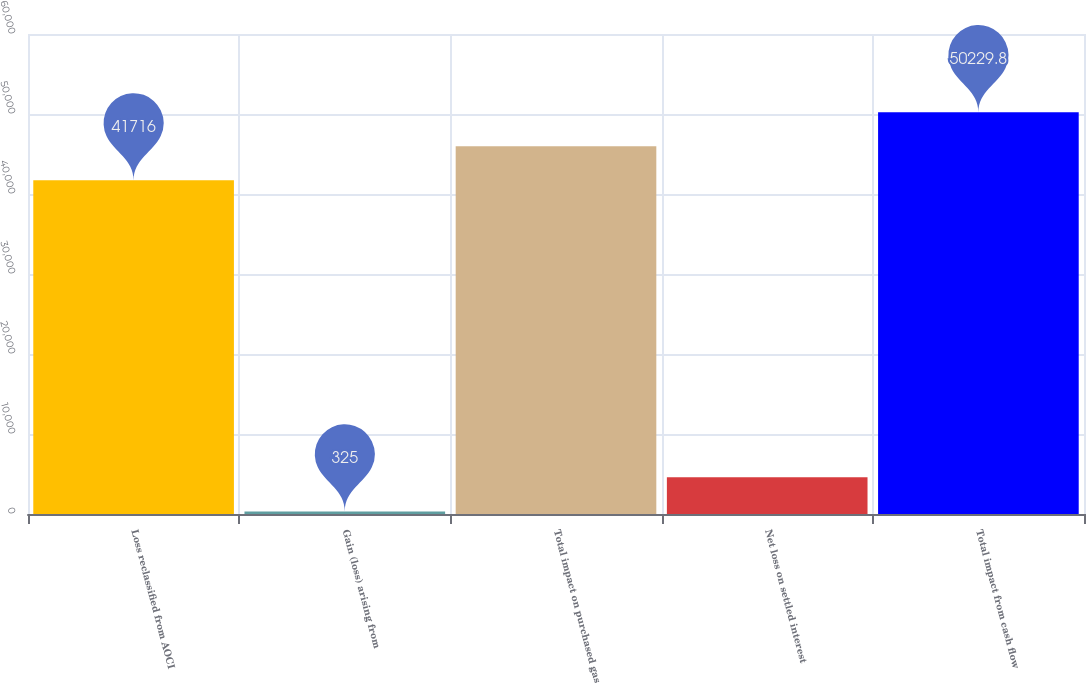<chart> <loc_0><loc_0><loc_500><loc_500><bar_chart><fcel>Loss reclassified from AOCI<fcel>Gain (loss) arising from<fcel>Total impact on purchased gas<fcel>Net loss on settled interest<fcel>Total impact from cash flow<nl><fcel>41716<fcel>325<fcel>45972.9<fcel>4581.9<fcel>50229.8<nl></chart> 